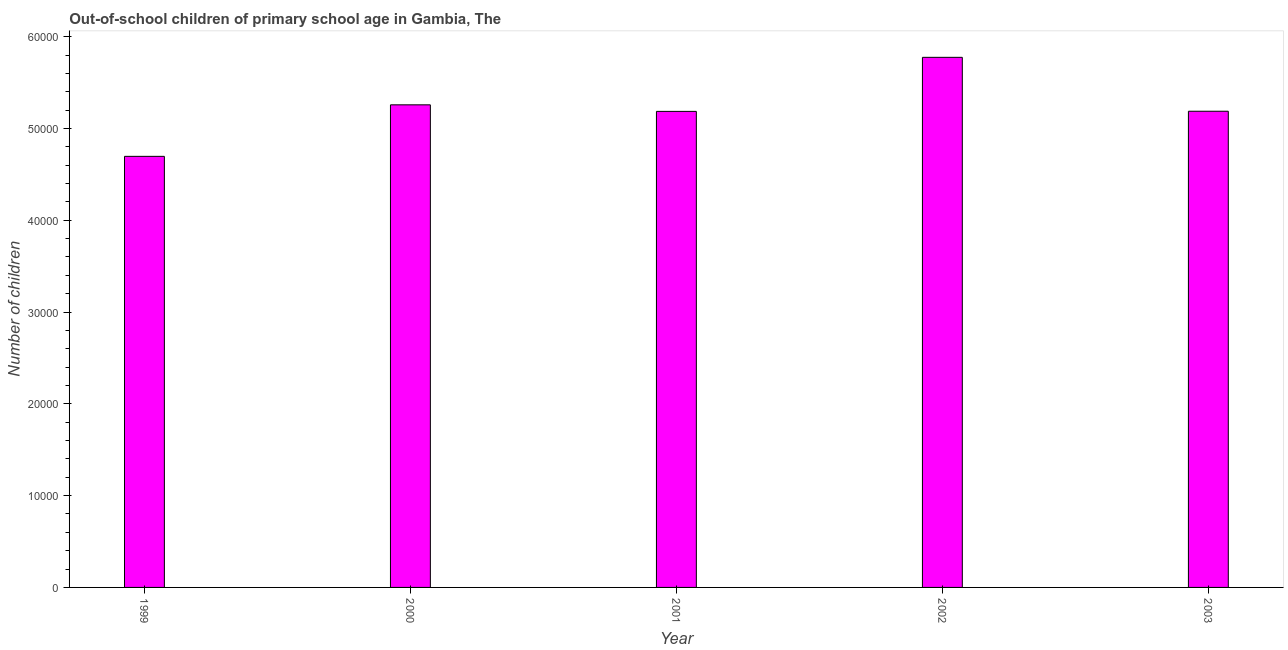Does the graph contain grids?
Your answer should be compact. No. What is the title of the graph?
Your answer should be very brief. Out-of-school children of primary school age in Gambia, The. What is the label or title of the Y-axis?
Your answer should be very brief. Number of children. What is the number of out-of-school children in 2002?
Offer a terse response. 5.77e+04. Across all years, what is the maximum number of out-of-school children?
Your answer should be very brief. 5.77e+04. Across all years, what is the minimum number of out-of-school children?
Offer a very short reply. 4.70e+04. In which year was the number of out-of-school children maximum?
Provide a succinct answer. 2002. In which year was the number of out-of-school children minimum?
Keep it short and to the point. 1999. What is the sum of the number of out-of-school children?
Give a very brief answer. 2.61e+05. What is the difference between the number of out-of-school children in 1999 and 2002?
Your answer should be very brief. -1.08e+04. What is the average number of out-of-school children per year?
Offer a very short reply. 5.22e+04. What is the median number of out-of-school children?
Keep it short and to the point. 5.19e+04. In how many years, is the number of out-of-school children greater than 58000 ?
Your response must be concise. 0. Do a majority of the years between 2003 and 2001 (inclusive) have number of out-of-school children greater than 52000 ?
Your answer should be very brief. Yes. What is the ratio of the number of out-of-school children in 2001 to that in 2002?
Provide a succinct answer. 0.9. Is the number of out-of-school children in 1999 less than that in 2001?
Offer a terse response. Yes. What is the difference between the highest and the second highest number of out-of-school children?
Your answer should be compact. 5175. Is the sum of the number of out-of-school children in 2000 and 2002 greater than the maximum number of out-of-school children across all years?
Keep it short and to the point. Yes. What is the difference between the highest and the lowest number of out-of-school children?
Your answer should be compact. 1.08e+04. Are all the bars in the graph horizontal?
Offer a terse response. No. How many years are there in the graph?
Provide a short and direct response. 5. What is the difference between two consecutive major ticks on the Y-axis?
Provide a short and direct response. 10000. Are the values on the major ticks of Y-axis written in scientific E-notation?
Your answer should be very brief. No. What is the Number of children of 1999?
Ensure brevity in your answer.  4.70e+04. What is the Number of children in 2000?
Offer a very short reply. 5.26e+04. What is the Number of children of 2001?
Provide a short and direct response. 5.19e+04. What is the Number of children of 2002?
Provide a short and direct response. 5.77e+04. What is the Number of children of 2003?
Provide a succinct answer. 5.19e+04. What is the difference between the Number of children in 1999 and 2000?
Offer a terse response. -5612. What is the difference between the Number of children in 1999 and 2001?
Give a very brief answer. -4898. What is the difference between the Number of children in 1999 and 2002?
Your answer should be very brief. -1.08e+04. What is the difference between the Number of children in 1999 and 2003?
Provide a succinct answer. -4913. What is the difference between the Number of children in 2000 and 2001?
Offer a terse response. 714. What is the difference between the Number of children in 2000 and 2002?
Provide a succinct answer. -5175. What is the difference between the Number of children in 2000 and 2003?
Keep it short and to the point. 699. What is the difference between the Number of children in 2001 and 2002?
Your response must be concise. -5889. What is the difference between the Number of children in 2002 and 2003?
Offer a very short reply. 5874. What is the ratio of the Number of children in 1999 to that in 2000?
Your answer should be very brief. 0.89. What is the ratio of the Number of children in 1999 to that in 2001?
Your response must be concise. 0.91. What is the ratio of the Number of children in 1999 to that in 2002?
Provide a succinct answer. 0.81. What is the ratio of the Number of children in 1999 to that in 2003?
Ensure brevity in your answer.  0.91. What is the ratio of the Number of children in 2000 to that in 2001?
Keep it short and to the point. 1.01. What is the ratio of the Number of children in 2000 to that in 2002?
Your answer should be very brief. 0.91. What is the ratio of the Number of children in 2001 to that in 2002?
Offer a very short reply. 0.9. What is the ratio of the Number of children in 2002 to that in 2003?
Give a very brief answer. 1.11. 